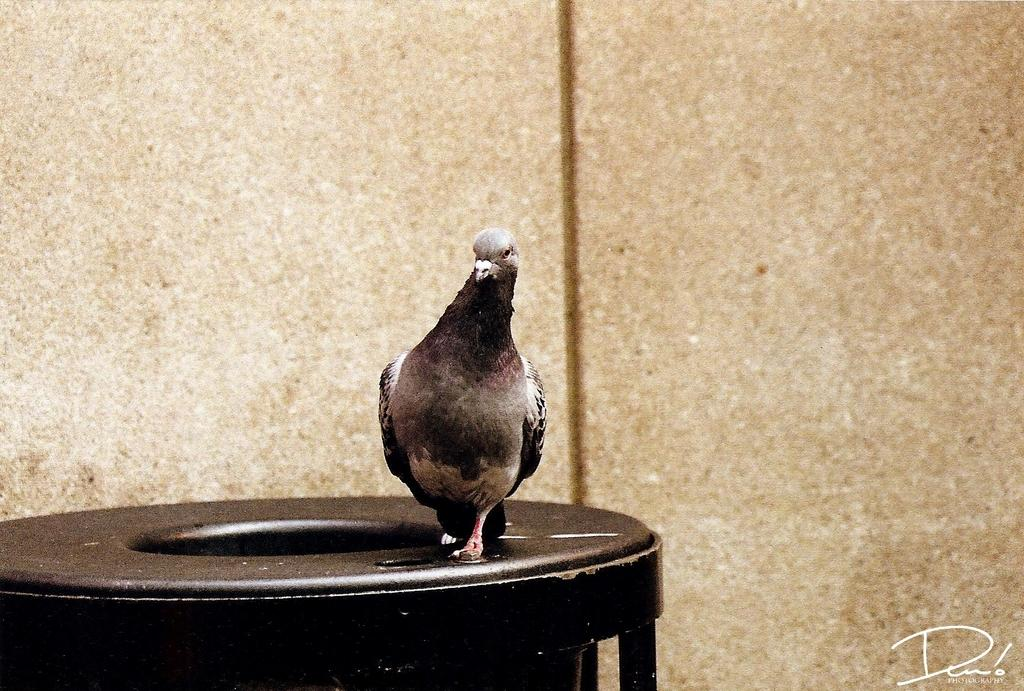What type of animal can be seen in the picture? There is a bird in the picture. What object is located at the bottom of the picture? There appears to be a dustbin at the bottom of the picture. What can be seen in the background of the picture? There is a wall in the background of the picture. Where is the text located in the picture? The text is at the bottom right corner of the picture. What type of sound does the cherry make as it rolls across the carriage in the image? There is no cherry or carriage present in the image, so this scenario cannot be observed. 